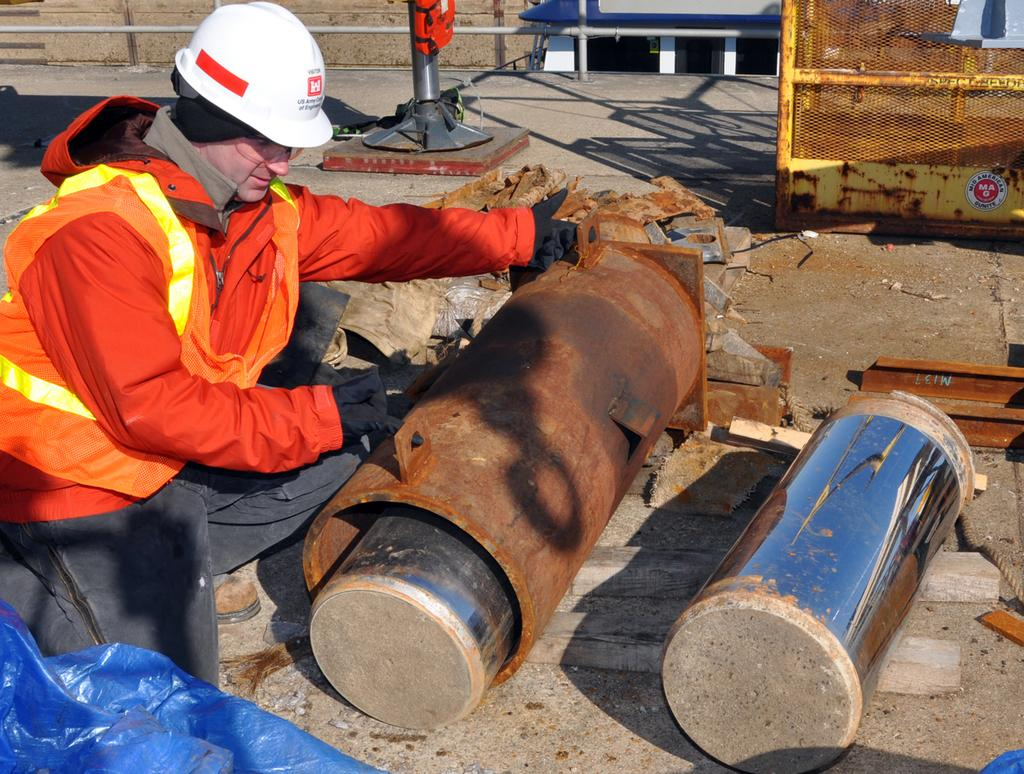What is the person in the image doing? There is a person sitting in the image. What can be seen on the ground in the image? There are two objects on the ground in the image. What is visible in the background of the image? There is a wall visible in the image. What type of nail is being used by the person in the image? There is no nail present in the image, and the person is sitting, not using any tools. 